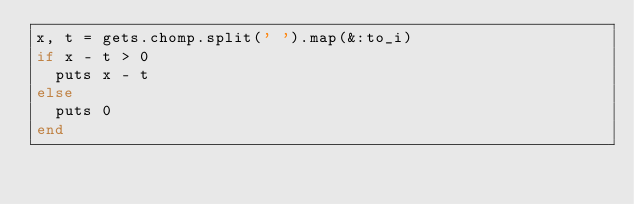<code> <loc_0><loc_0><loc_500><loc_500><_Ruby_>x, t = gets.chomp.split(' ').map(&:to_i)
if x - t > 0
  puts x - t
else
  puts 0
end</code> 